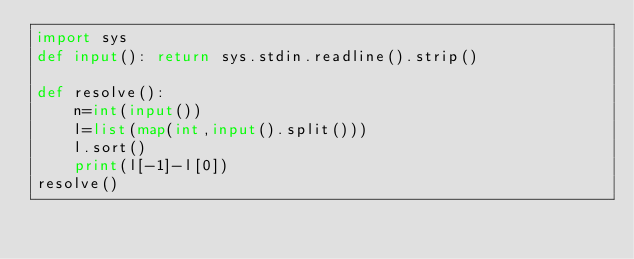<code> <loc_0><loc_0><loc_500><loc_500><_Python_>import sys
def input(): return sys.stdin.readline().strip()

def resolve():
    n=int(input())
    l=list(map(int,input().split()))
    l.sort()
    print(l[-1]-l[0])
resolve()</code> 